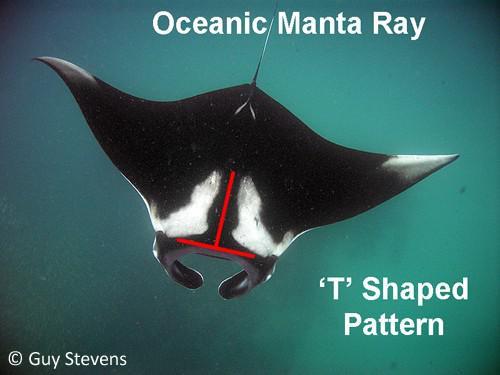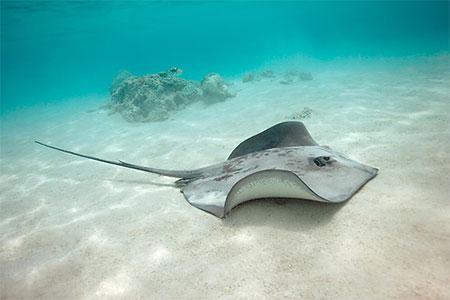The first image is the image on the left, the second image is the image on the right. Given the left and right images, does the statement "There is exactly one manta ray." hold true? Answer yes or no. Yes. The first image is the image on the left, the second image is the image on the right. For the images displayed, is the sentence "The right image shows the complete underbelly of a manta ray." factually correct? Answer yes or no. No. 